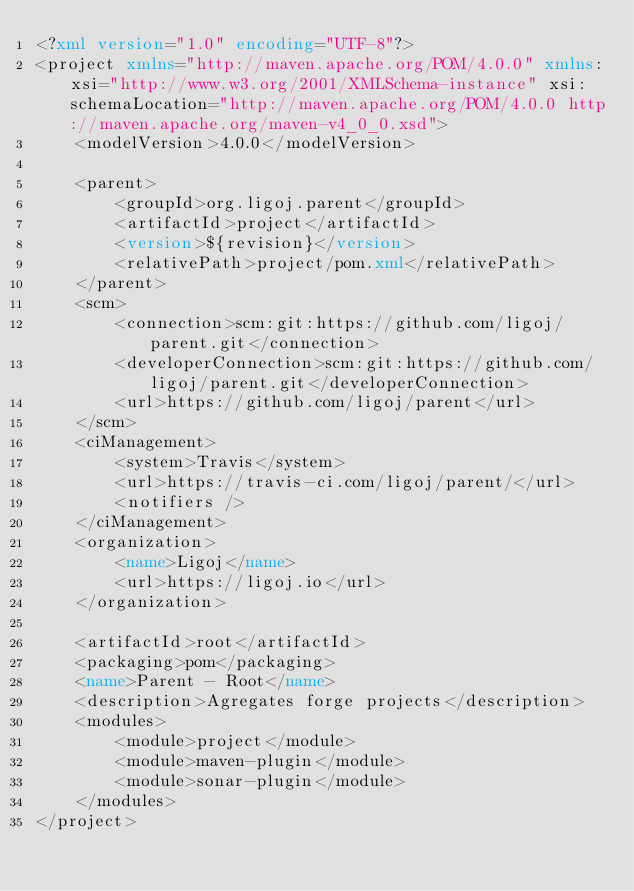Convert code to text. <code><loc_0><loc_0><loc_500><loc_500><_XML_><?xml version="1.0" encoding="UTF-8"?>
<project xmlns="http://maven.apache.org/POM/4.0.0" xmlns:xsi="http://www.w3.org/2001/XMLSchema-instance" xsi:schemaLocation="http://maven.apache.org/POM/4.0.0 http://maven.apache.org/maven-v4_0_0.xsd">
	<modelVersion>4.0.0</modelVersion>

	<parent>
		<groupId>org.ligoj.parent</groupId>
		<artifactId>project</artifactId>
		<version>${revision}</version>
		<relativePath>project/pom.xml</relativePath>
	</parent>
	<scm>
		<connection>scm:git:https://github.com/ligoj/parent.git</connection>
		<developerConnection>scm:git:https://github.com/ligoj/parent.git</developerConnection>
		<url>https://github.com/ligoj/parent</url>
	</scm>
	<ciManagement>
		<system>Travis</system>
		<url>https://travis-ci.com/ligoj/parent/</url>
		<notifiers />
	</ciManagement>
	<organization>
		<name>Ligoj</name>
		<url>https://ligoj.io</url>
	</organization>

	<artifactId>root</artifactId>
	<packaging>pom</packaging>
	<name>Parent - Root</name>
	<description>Agregates forge projects</description>
	<modules>
		<module>project</module>
		<module>maven-plugin</module>
		<module>sonar-plugin</module>
	</modules>
</project>

</code> 